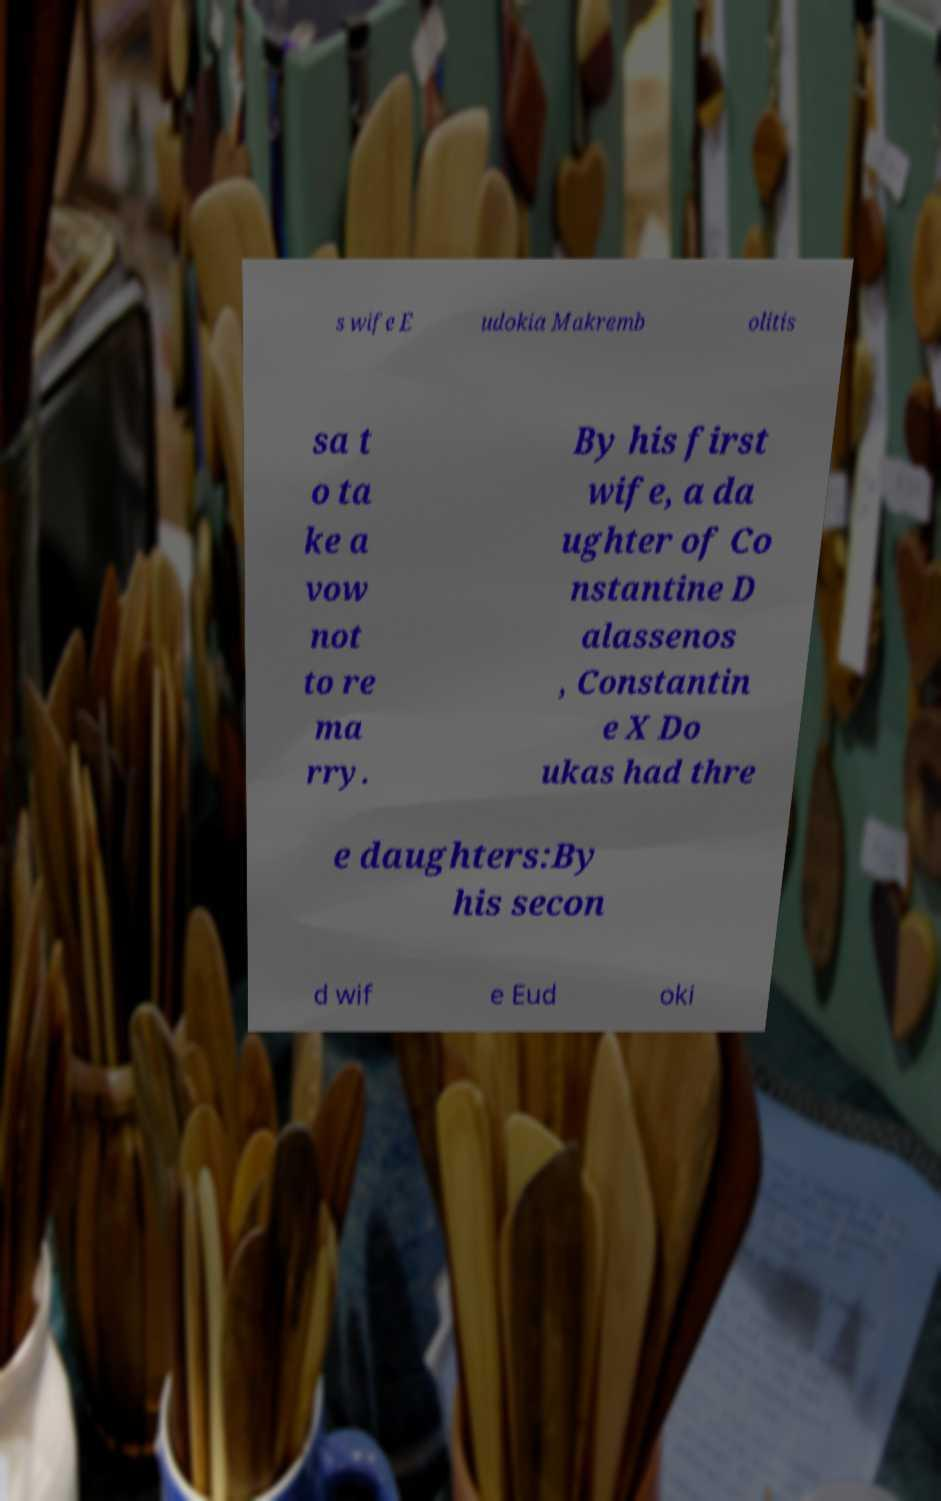What messages or text are displayed in this image? I need them in a readable, typed format. s wife E udokia Makremb olitis sa t o ta ke a vow not to re ma rry. By his first wife, a da ughter of Co nstantine D alassenos , Constantin e X Do ukas had thre e daughters:By his secon d wif e Eud oki 